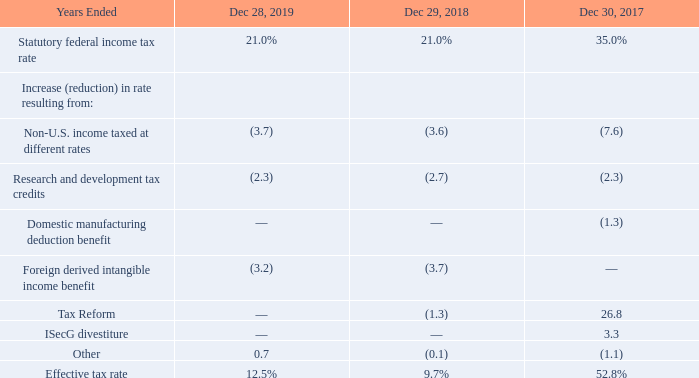The difference between the tax provision at the statutory federal income tax rate and the tax provision as a percentage of income before income taxes (effective tax rate) for each period was as follows:
The majority of the increase in our effective tax rate in 2019 compared to 2018 was driven by one-time benefits that occurred in 2018.
The majority of the decrease in our effective tax rate in 2018 compared to 2017 resulted from initial tax expense from Tax Reform and the tax impacts from the ISecG divestiture that we had in 2017, but not in 2018. The reduction of the U.S. statutory rate, combined with the net impact of the enactment or repeal of specific tax law provisions through Tax Reform, drove the remaining decrease in our effective tax rate in 2018.
We derive the effective tax rate benefit attributed to non-U.S. income taxed at different rates primarily from our operations in China, Hong Kong, Ireland, and Israel. The statutory tax rates in these jurisdictions range from 12.5% to 25.0%. In addition, we are subject to reduced tax rates in China and Israel as long as we conduct certain eligible activities and make certain capital investments. These conditional reduced tax rates expire at various dates through 2026 and we expect to apply for renewals upon expiration.
What is the effective tax rate in the year 2017, 2018, and 2019 respectively? 52.8%, 9.7%, 12.5%. What was the major driver for the increase in effective tax rate in 2019 compared to 2018? One-time benefits that occurred in 2018. What does the table show? The difference between the tax provision at the statutory federal income tax rate and the tax provision as a percentage of income before income taxes (effective tax rate) for each period. What is the percentage change of the effective tax rate from 2018 to 2019?
Answer scale should be: percent. (12.5 - 9.7) / 9.7 
Answer: 28.87. What is the average effective tax rate from 2017 to 2019?
Answer scale should be: percent. (52.8 + 9.7 + 12.5) / 3 
Answer: 25. What is the change of the tax expenses of Tax Reform from 2017 to 2018?
Answer scale should be: percent. (-1.3)-26.8 
Answer: -28.1. 